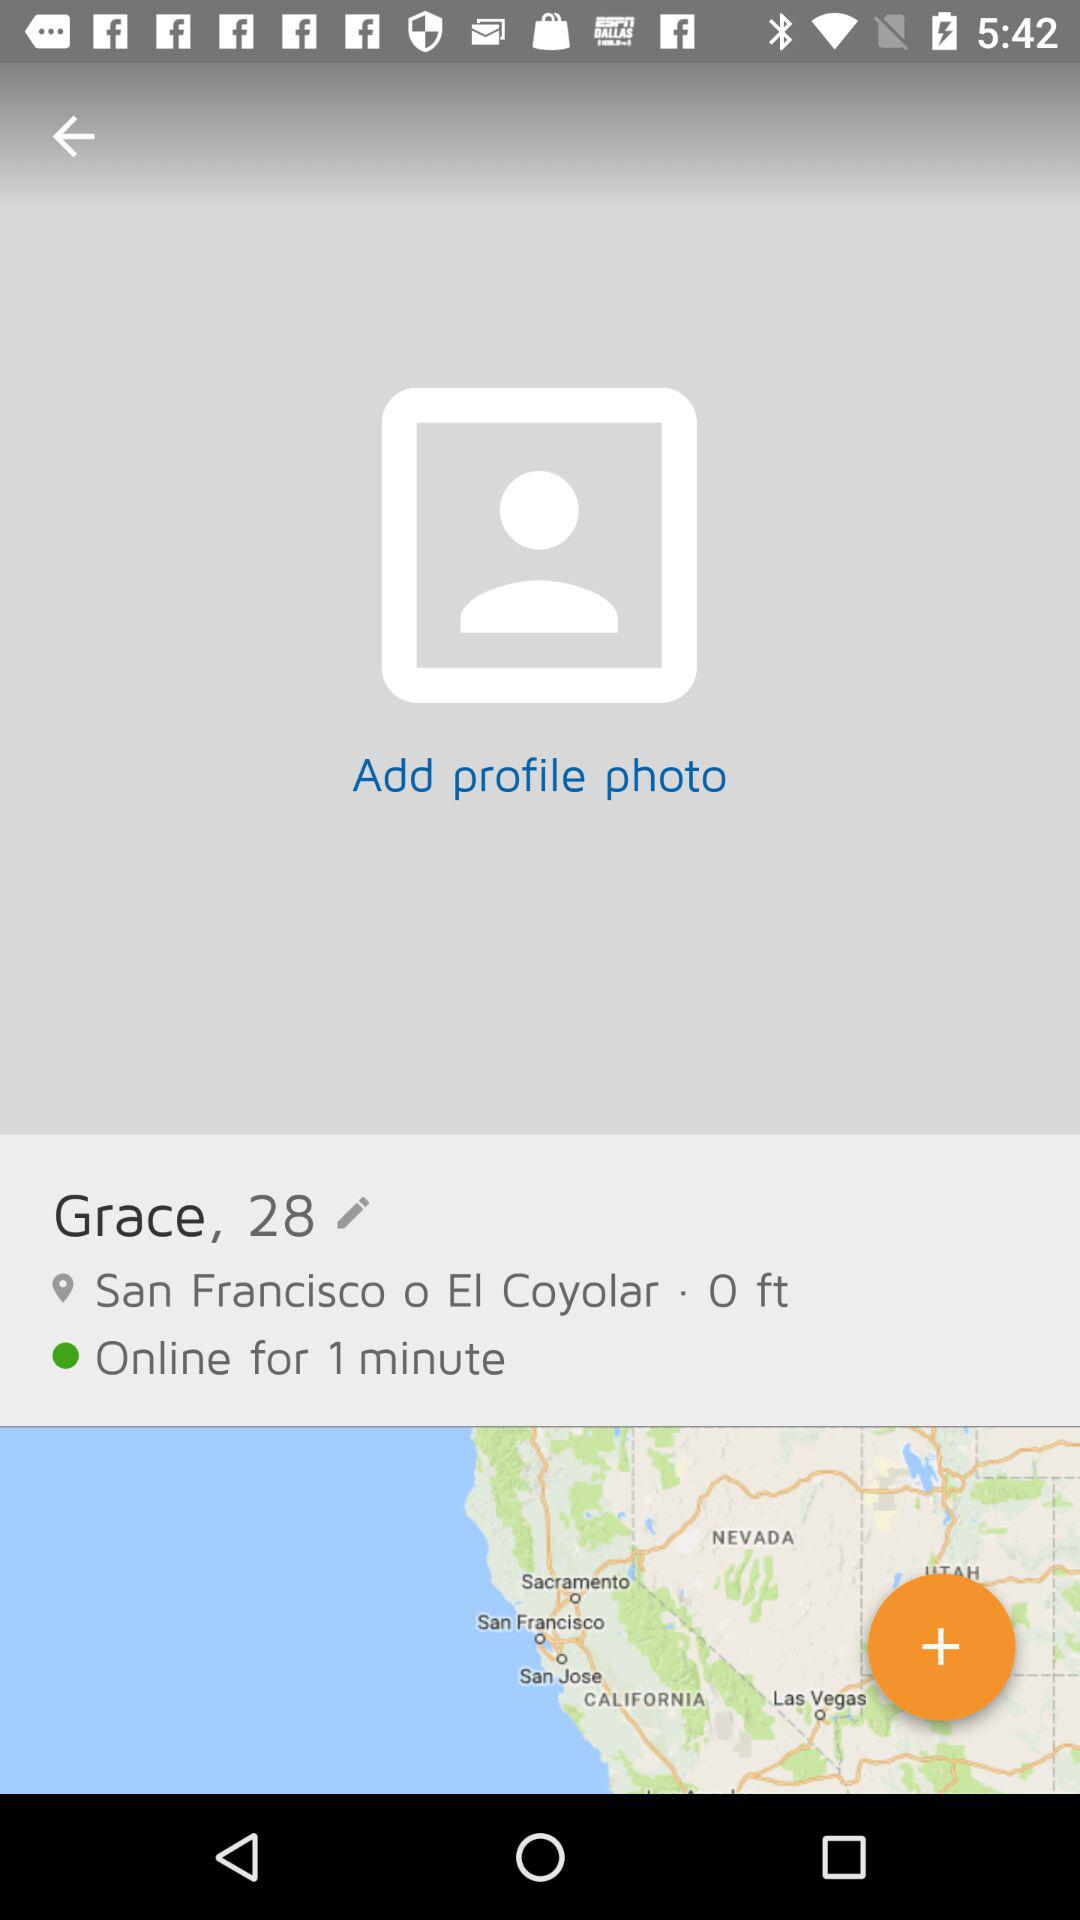How many profile photos has Grace added?
When the provided information is insufficient, respond with <no answer>. <no answer> 